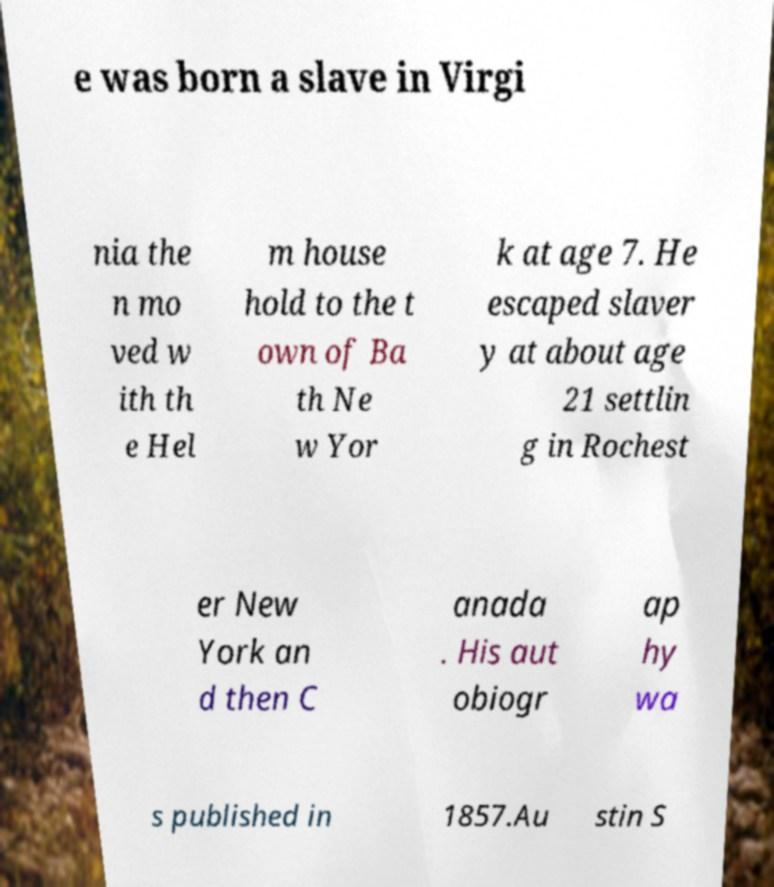Please identify and transcribe the text found in this image. e was born a slave in Virgi nia the n mo ved w ith th e Hel m house hold to the t own of Ba th Ne w Yor k at age 7. He escaped slaver y at about age 21 settlin g in Rochest er New York an d then C anada . His aut obiogr ap hy wa s published in 1857.Au stin S 